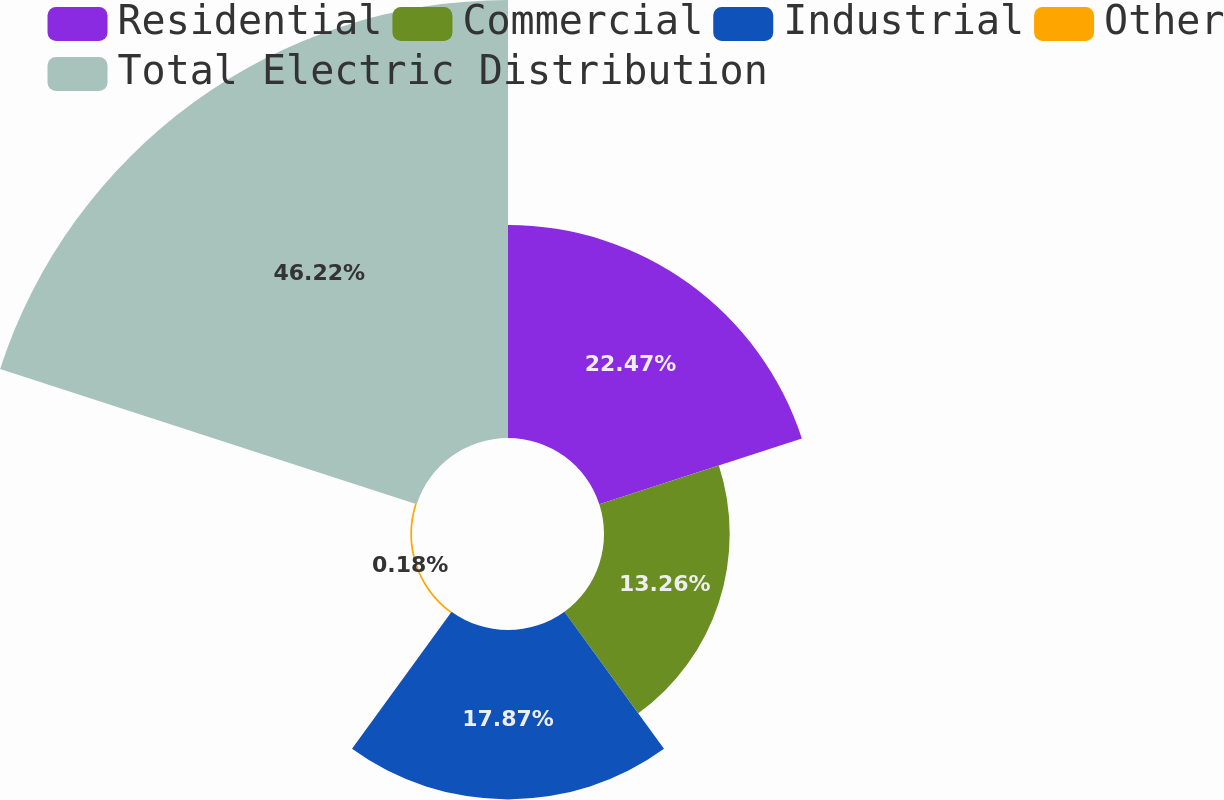Convert chart. <chart><loc_0><loc_0><loc_500><loc_500><pie_chart><fcel>Residential<fcel>Commercial<fcel>Industrial<fcel>Other<fcel>Total Electric Distribution<nl><fcel>22.47%<fcel>13.26%<fcel>17.87%<fcel>0.18%<fcel>46.21%<nl></chart> 